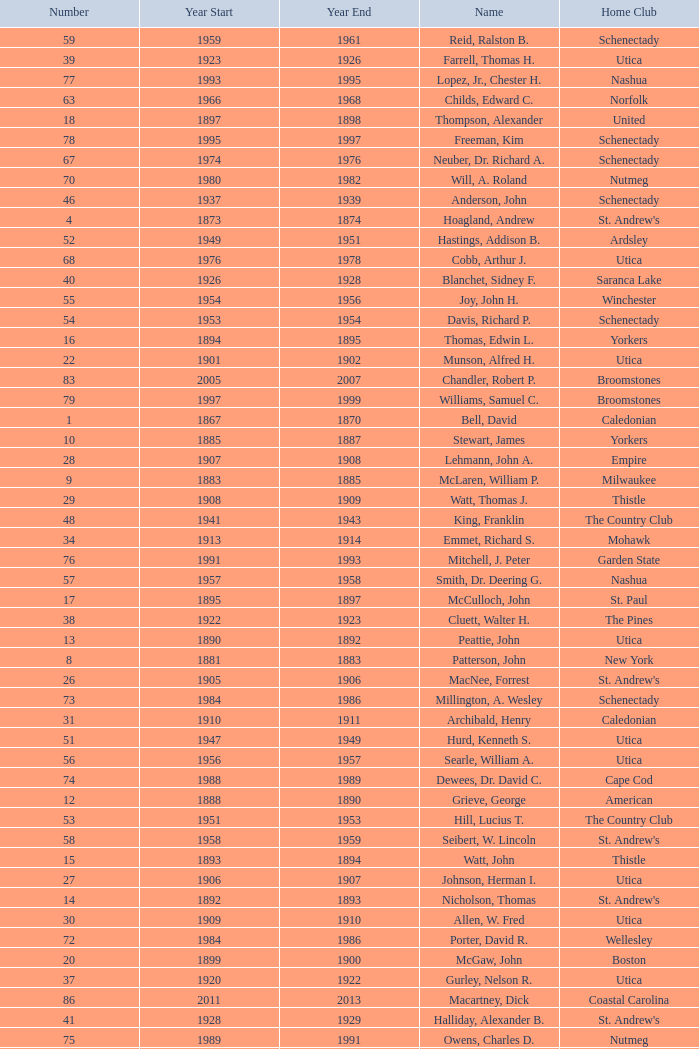Which Number has a Name of cooper, c. kenneth, and a Year End larger than 1984? None. Give me the full table as a dictionary. {'header': ['Number', 'Year Start', 'Year End', 'Name', 'Home Club'], 'rows': [['59', '1959', '1961', 'Reid, Ralston B.', 'Schenectady'], ['39', '1923', '1926', 'Farrell, Thomas H.', 'Utica'], ['77', '1993', '1995', 'Lopez, Jr., Chester H.', 'Nashua'], ['63', '1966', '1968', 'Childs, Edward C.', 'Norfolk'], ['18', '1897', '1898', 'Thompson, Alexander', 'United'], ['78', '1995', '1997', 'Freeman, Kim', 'Schenectady'], ['67', '1974', '1976', 'Neuber, Dr. Richard A.', 'Schenectady'], ['70', '1980', '1982', 'Will, A. Roland', 'Nutmeg'], ['46', '1937', '1939', 'Anderson, John', 'Schenectady'], ['4', '1873', '1874', 'Hoagland, Andrew', "St. Andrew's"], ['52', '1949', '1951', 'Hastings, Addison B.', 'Ardsley'], ['68', '1976', '1978', 'Cobb, Arthur J.', 'Utica'], ['40', '1926', '1928', 'Blanchet, Sidney F.', 'Saranca Lake'], ['55', '1954', '1956', 'Joy, John H.', 'Winchester'], ['54', '1953', '1954', 'Davis, Richard P.', 'Schenectady'], ['16', '1894', '1895', 'Thomas, Edwin L.', 'Yorkers'], ['22', '1901', '1902', 'Munson, Alfred H.', 'Utica'], ['83', '2005', '2007', 'Chandler, Robert P.', 'Broomstones'], ['79', '1997', '1999', 'Williams, Samuel C.', 'Broomstones'], ['1', '1867', '1870', 'Bell, David', 'Caledonian'], ['10', '1885', '1887', 'Stewart, James', 'Yorkers'], ['28', '1907', '1908', 'Lehmann, John A.', 'Empire'], ['9', '1883', '1885', 'McLaren, William P.', 'Milwaukee'], ['29', '1908', '1909', 'Watt, Thomas J.', 'Thistle'], ['48', '1941', '1943', 'King, Franklin', 'The Country Club'], ['34', '1913', '1914', 'Emmet, Richard S.', 'Mohawk'], ['76', '1991', '1993', 'Mitchell, J. Peter', 'Garden State'], ['57', '1957', '1958', 'Smith, Dr. Deering G.', 'Nashua'], ['17', '1895', '1897', 'McCulloch, John', 'St. Paul'], ['38', '1922', '1923', 'Cluett, Walter H.', 'The Pines'], ['13', '1890', '1892', 'Peattie, John', 'Utica'], ['8', '1881', '1883', 'Patterson, John', 'New York'], ['26', '1905', '1906', 'MacNee, Forrest', "St. Andrew's"], ['73', '1984', '1986', 'Millington, A. Wesley', 'Schenectady'], ['31', '1910', '1911', 'Archibald, Henry', 'Caledonian'], ['51', '1947', '1949', 'Hurd, Kenneth S.', 'Utica'], ['56', '1956', '1957', 'Searle, William A.', 'Utica'], ['74', '1988', '1989', 'Dewees, Dr. David C.', 'Cape Cod'], ['12', '1888', '1890', 'Grieve, George', 'American'], ['53', '1951', '1953', 'Hill, Lucius T.', 'The Country Club'], ['58', '1958', '1959', 'Seibert, W. Lincoln', "St. Andrew's"], ['15', '1893', '1894', 'Watt, John', 'Thistle'], ['27', '1906', '1907', 'Johnson, Herman I.', 'Utica'], ['14', '1892', '1893', 'Nicholson, Thomas', "St. Andrew's"], ['30', '1909', '1910', 'Allen, W. Fred', 'Utica'], ['72', '1984', '1986', 'Porter, David R.', 'Wellesley'], ['20', '1899', '1900', 'McGaw, John', 'Boston'], ['37', '1920', '1922', 'Gurley, Nelson R.', 'Utica'], ['86', '2011', '2013', 'Macartney, Dick', 'Coastal Carolina'], ['41', '1928', '1929', 'Halliday, Alexander B.', "St. Andrew's"], ['75', '1989', '1991', 'Owens, Charles D.', 'Nutmeg'], ['49', '1943', '1945', 'Lydgate, Theodore H.', 'Schenectady'], ['81', '2001', '2003', 'Garber, Thomas', 'Utica'], ['36', '1916', '1920', 'Vaughen, Frank G.', 'Mohawk'], ['11', '1887', '1888', 'McArthur, John', 'Chicago'], ['19', '1898', '1899', 'Morrison, David G.', 'Manhattan'], ['35', '1914', '1916', 'Johnson, Delos M.', 'Utica'], ['25', '1904', '1905', 'Allen, George B.', 'Utica'], ['3', '1872', '1873', 'Macnoe, George', 'Caledonian'], ['64', '1968', '1970', 'Rand, Grenfell N.', 'Albany'], ['6', '1877', '1879', 'Johnston, John', 'Milwaukee'], ['24', '1903', '1904', 'Thaw, James', 'Thistle'], ['60', '1961', '1963', 'Cushing, Henry K.', 'The Country Club'], ['2', '1870', '1872', 'Dalrymple, Alexander', "St. Andrew's"], ['21', '1900', '1901', 'Conley, James F.', 'Empire City'], ['32', '1911', '1912', 'Calder, Frederick M.', 'Utica'], ['23', '1902', '1903', 'Edwards, William D.', 'Jersey City'], ['69', '1978', '1980', 'Hamm, Arthur E.', 'Petersham'], ['62', '1965', '1966', 'Parkinson, Fred E.', 'Utica'], ['47', '1939', '1941', 'Davies, Robert L.', 'Utica'], ['82', '2003', '2005', 'Pelletier, Robert', 'Potomac'], ['65', '1970', '1972', 'Neill, Stanley E.', 'Winchester'], ['43', '1931', '1933', 'Porter, Alexander S.', 'The Country Club'], ['66', '1972', '1974', 'Milano, Dr. Joseph E.', 'NY Caledonian'], ['50', '1945', '1947', 'Williamson, Clifton P.', "St. Andrew's"], ['42', '1929', '1931', 'Curran, Sherwood S.', 'Utica'], ['7', '1879', '1881', 'Stevens, James', 'Jersey City'], ['45', '1935', '1937', 'Patterson, Jr., C. Campbell', 'The Country Club'], ['33', '1912', '1913', 'Peene, George W.', 'Yorkers'], ['85', '2009', '2011', 'Thomas, Carl', 'Utica'], ['5', '1874', '1877', 'Hamilton, John L.', 'Caledonian'], ['44', '1933', '1935', 'Calder, John W.', 'Utica'], ['61', '1963', '1965', 'Wood, Brenner R.', 'Ardsley'], ['80', '1999', '2001', 'Hatch, Peggy', 'Philadelphia'], ['84', '2007', '2009', 'Krailo, Gwen', 'Nashua'], ['71', '1982', '1984', 'Cooper, C. Kenneth', 'NY Caledonian']]} 